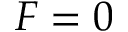<formula> <loc_0><loc_0><loc_500><loc_500>F = 0</formula> 